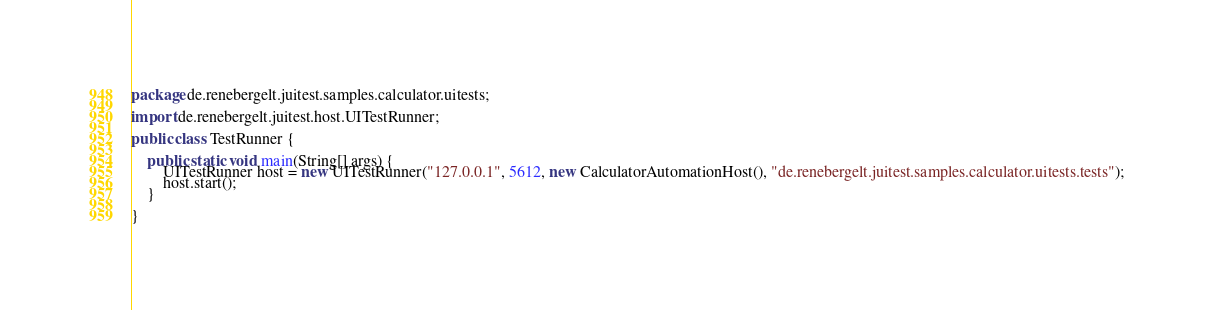Convert code to text. <code><loc_0><loc_0><loc_500><loc_500><_Java_>package de.renebergelt.juitest.samples.calculator.uitests;

import de.renebergelt.juitest.host.UITestRunner;

public class TestRunner {

    public static void main(String[] args) {
        UITestRunner host = new UITestRunner("127.0.0.1", 5612, new CalculatorAutomationHost(), "de.renebergelt.juitest.samples.calculator.uitests.tests");
        host.start();
    }

}
</code> 